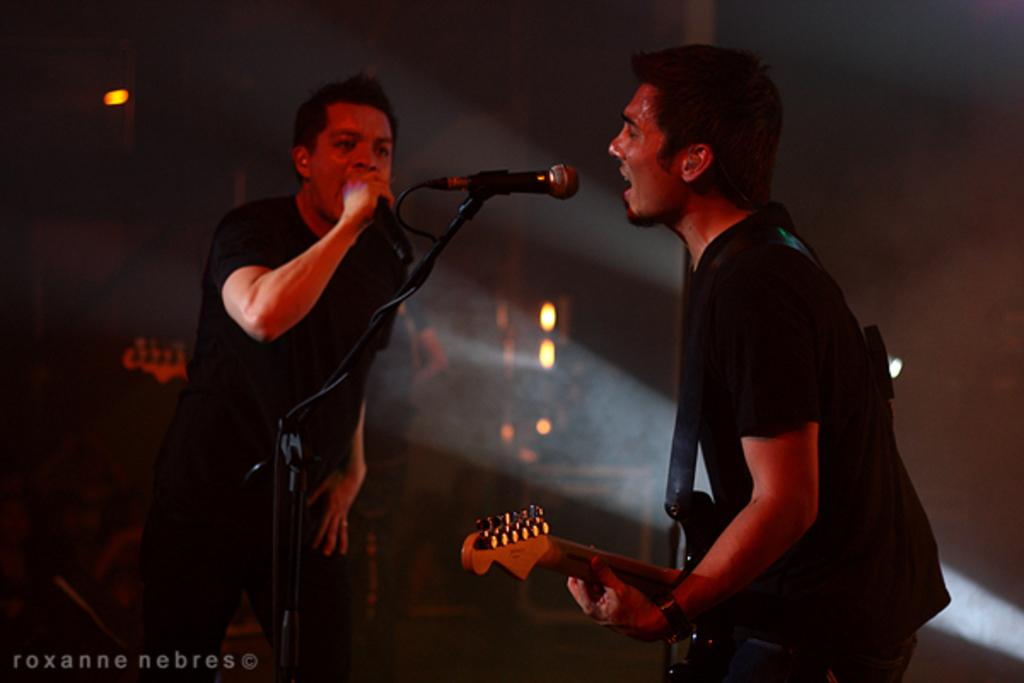How many people are in the image? There are two persons standing in the image. What is one of the men doing in the image? One man is playing a guitar. What activity are both men engaged in? Both men are singing in front of a microphone. What can be seen in the background of the image? There are lights visible in the image. What type of houses can be seen in the background of the image? There are no houses visible in the image; it features two men singing and playing a guitar in front of lights. 